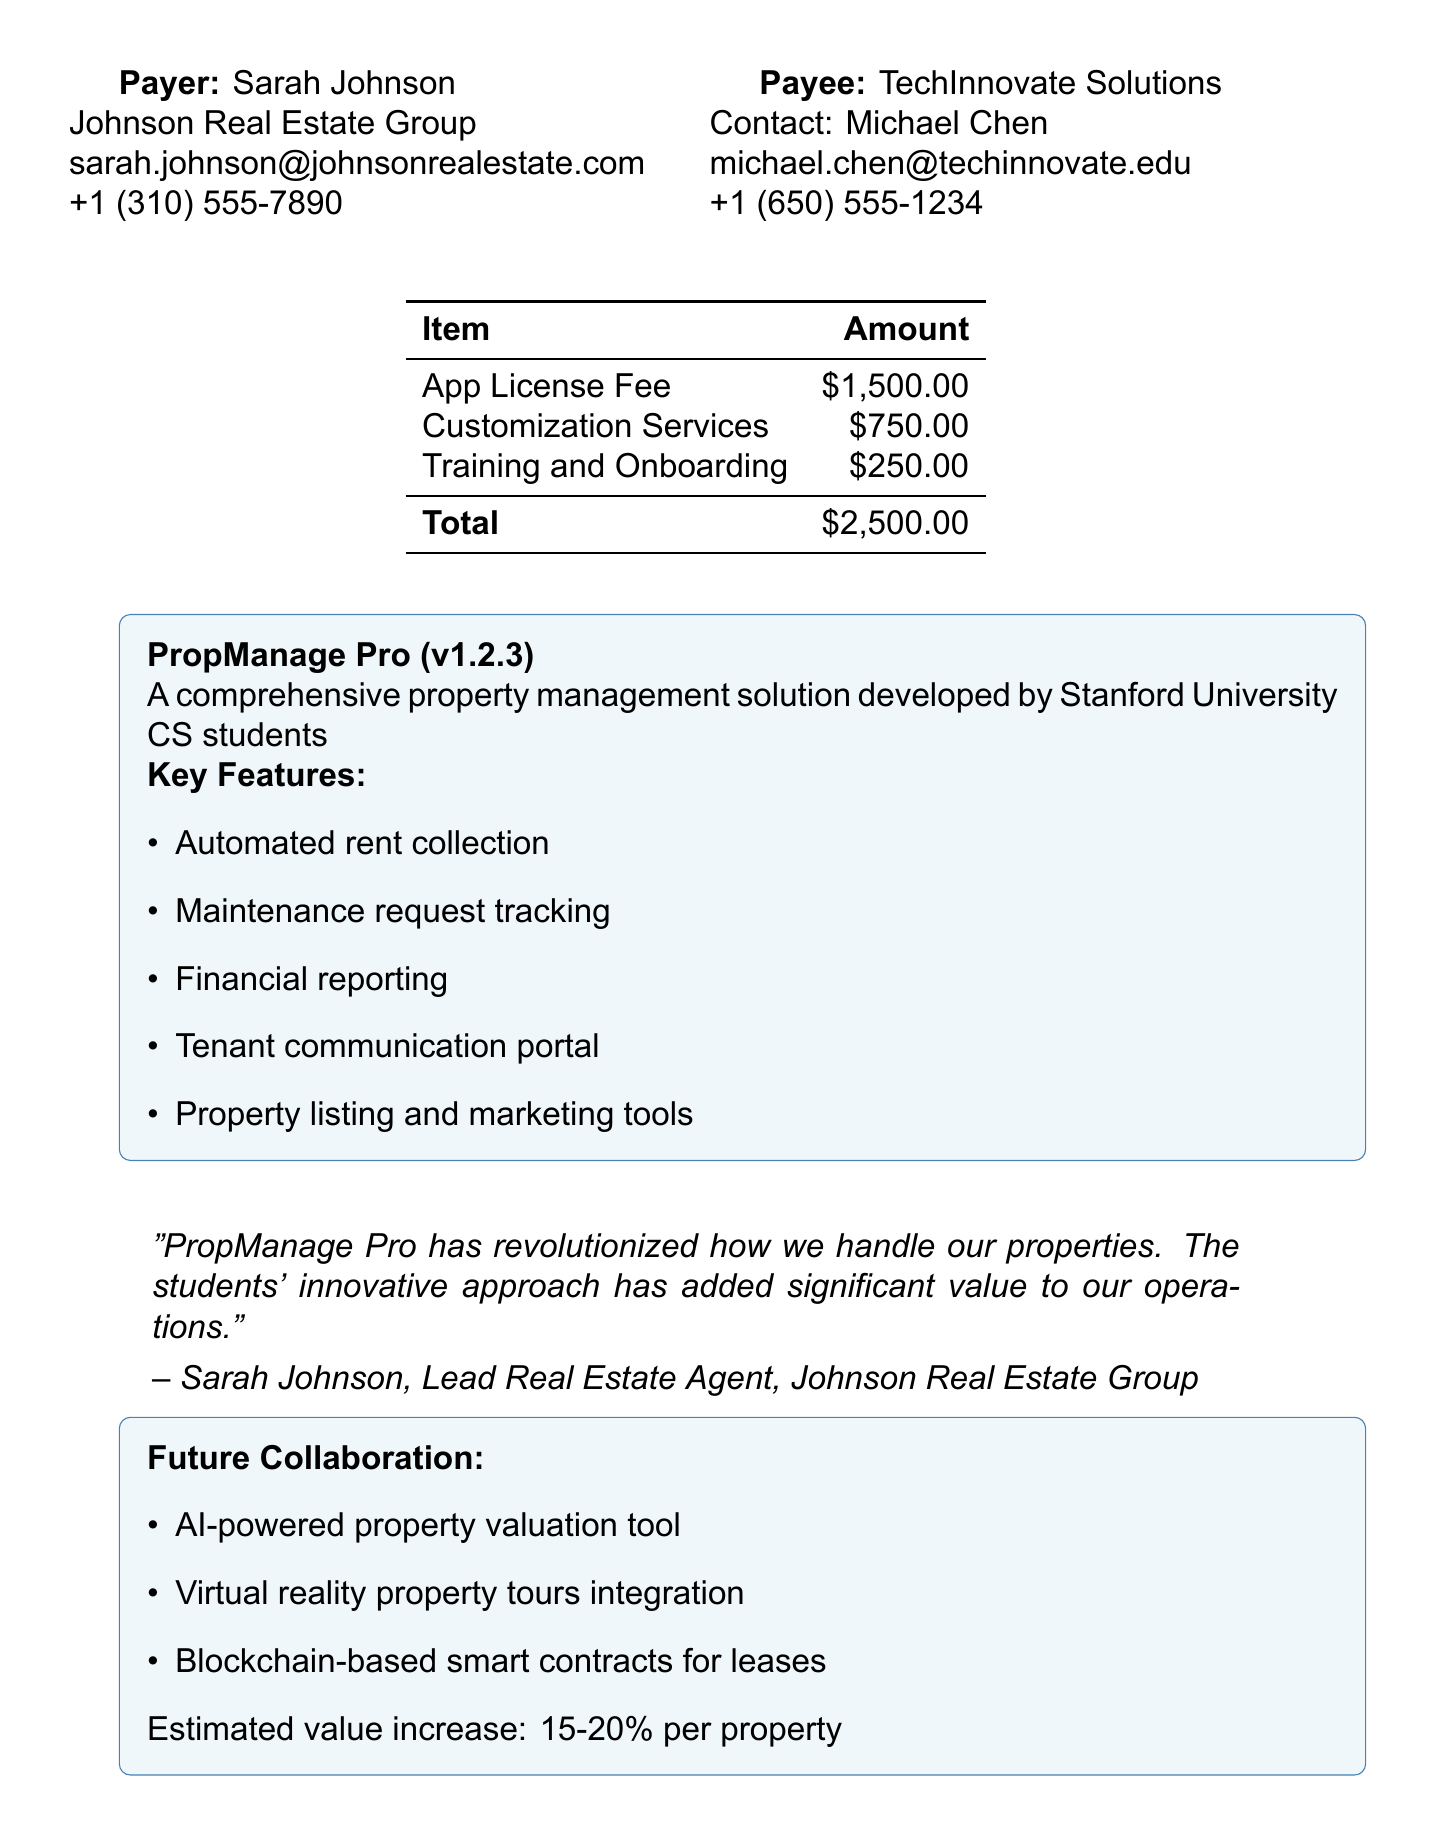What is the transaction ID? The transaction ID is specified at the top of the document, which identifies the payment record.
Answer: PMT-23789-SDPA What was the payment amount? The payment amount is indicated in the transaction details section of the document.
Answer: $2,500.00 Who is the contact person for the payee? The contact person for TechInnovate Solutions is mentioned in the payee information section.
Answer: Michael Chen What features does PropManage Pro offer? The document lists key features of the property management app in the app details section, which contributes to its functionality.
Answer: Automated rent collection, Maintenance request tracking, Financial reporting, Tenant communication portal, Property listing and marketing tools What is included in the support? Support details provided mention the type of support included for the app users.
Answer: Email and phone support during business hours What is the estimated value increase through future collaborations? The document highlights the potential increase in property value resulting from proposed projects in the future collaboration section.
Answer: 15-20% What is the duration of the contract? The length of the contract is specified in the additional information section.
Answer: 12 months What did Sarah Johnson say about PropManage Pro? A quote from Sarah Johnson in the testimonial section reflects her opinion regarding the app's impact.
Answer: "PropManage Pro has revolutionized how we handle our properties." 